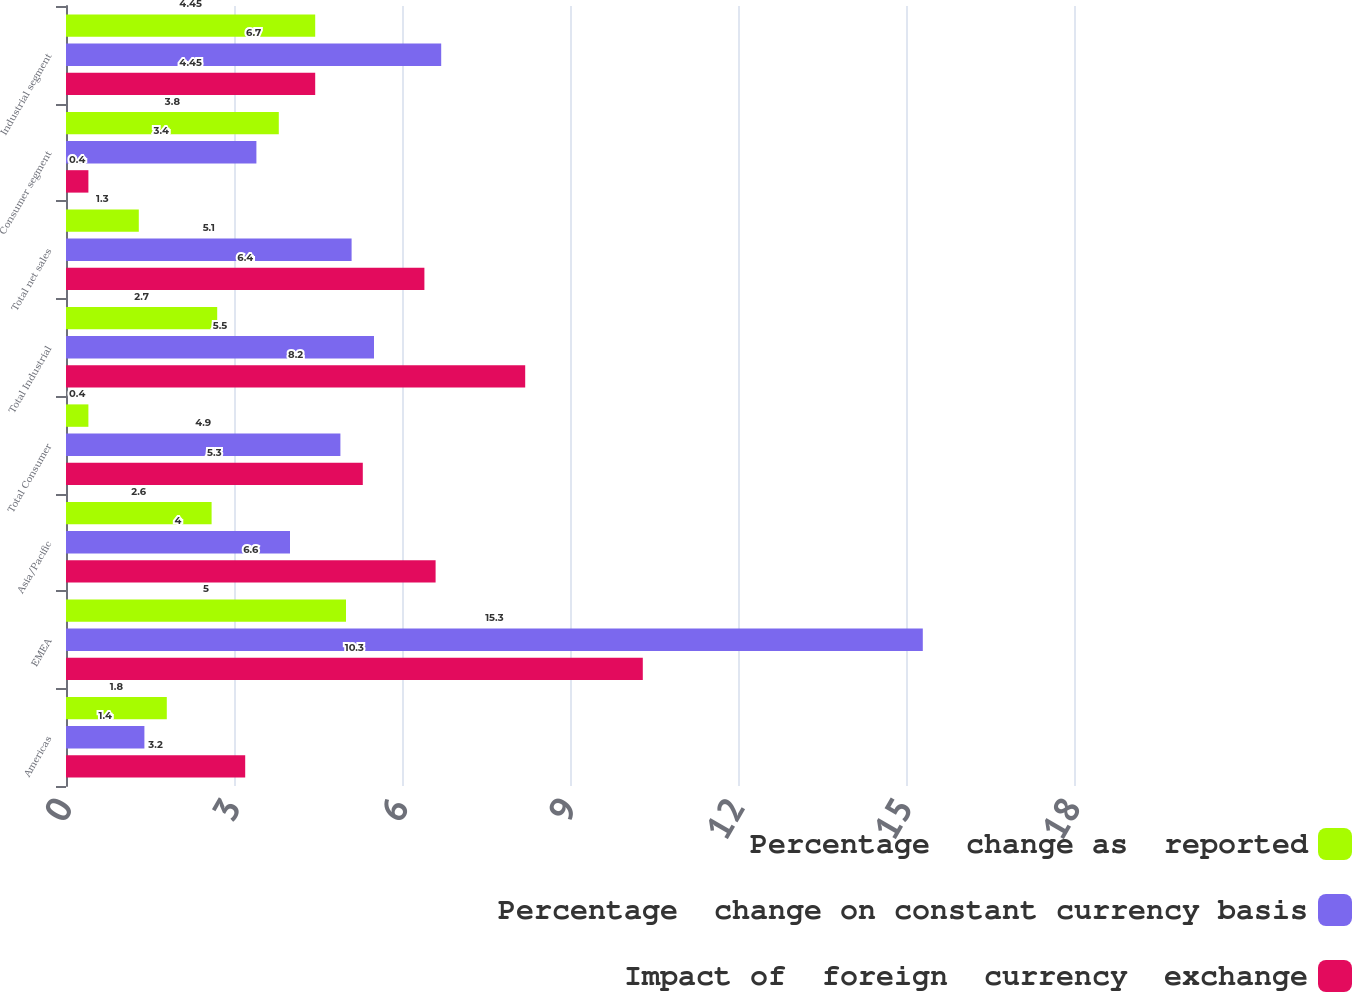Convert chart to OTSL. <chart><loc_0><loc_0><loc_500><loc_500><stacked_bar_chart><ecel><fcel>Americas<fcel>EMEA<fcel>Asia/Pacific<fcel>Total Consumer<fcel>Total Industrial<fcel>Total net sales<fcel>Consumer segment<fcel>Industrial segment<nl><fcel>Percentage  change as  reported<fcel>1.8<fcel>5<fcel>2.6<fcel>0.4<fcel>2.7<fcel>1.3<fcel>3.8<fcel>4.45<nl><fcel>Percentage  change on constant currency basis<fcel>1.4<fcel>15.3<fcel>4<fcel>4.9<fcel>5.5<fcel>5.1<fcel>3.4<fcel>6.7<nl><fcel>Impact of  foreign  currency  exchange<fcel>3.2<fcel>10.3<fcel>6.6<fcel>5.3<fcel>8.2<fcel>6.4<fcel>0.4<fcel>4.45<nl></chart> 